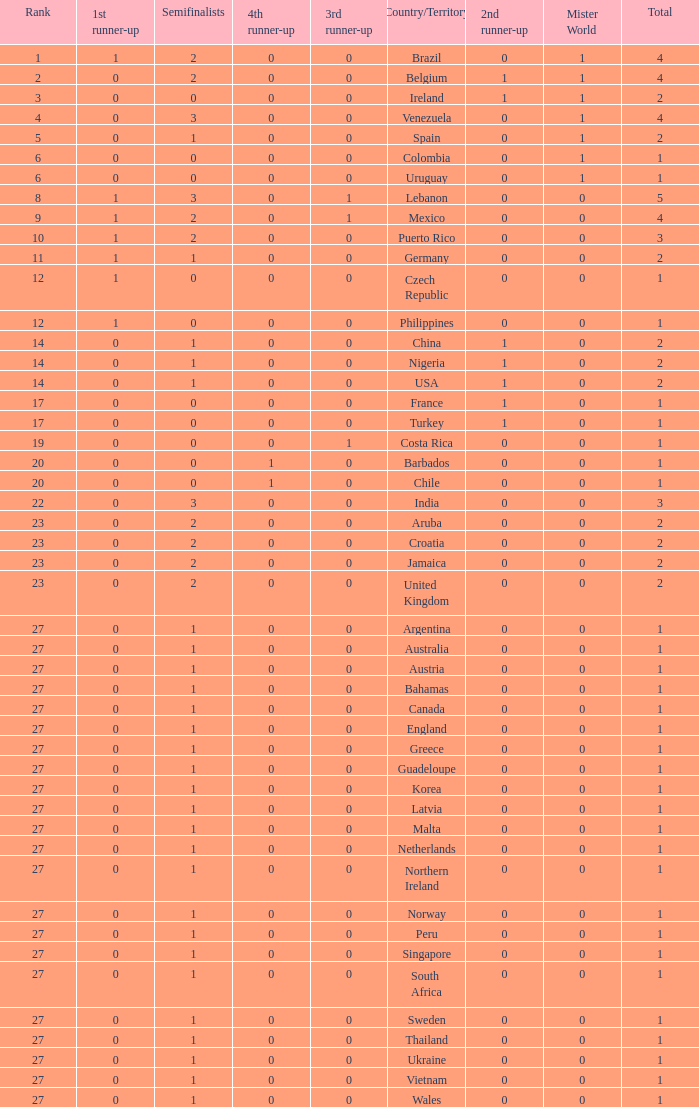What is the smallest 1st runner up value? 0.0. 